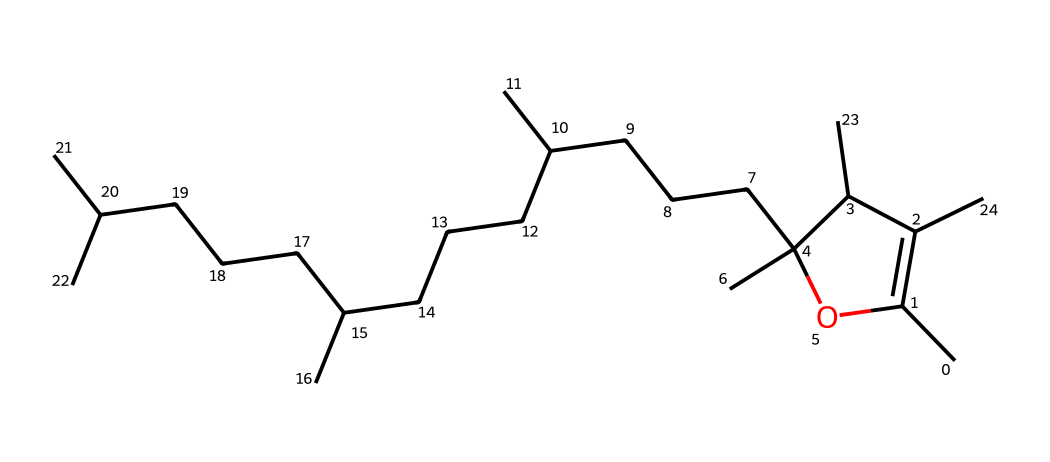What is the primary functional group present in this chemical structure? The chemical structure contains a hydroxyl group (-OH), which is indicated by the oxygen atom bonded to a carbon atom. This is a characteristic feature of alcohols and is essential for the activity of vitamin E.
Answer: hydroxyl How many carbon atoms are present in this structure? By examining the SMILES representation, we can count the number of carbon atoms within the rings and chain structure, leading us to identify a total of 29 carbon atoms.
Answer: 29 What type of vitamin is represented by this chemical structure? The structure corresponds to vitamin E, particularly as it includes the tocopherol group commonly associated with this vitamin's activity and function.
Answer: vitamin E Which isomer of tocopherol does this structure represent? Analyzing the specific arrangement and substituents, this structure indicates that it is alpha-tocopherol, characterized by the presence of a methyl group on the chromanol ring.
Answer: alpha-tocopherol What structural feature distinguishes alpha-tocopherol from gamma-tocopherol? The key structural difference lies in the number of methyl groups on the chromanol ring; alpha-tocopherol has three, while gamma-tocopherol only has two.
Answer: methyl groups What is the longest carbon chain in this structure? The chemical contains a long hydrocarbon tail with a total of 12 carbon atoms that layout as a saturated alkyl side chain connected to the chromanol ring.
Answer: 12 